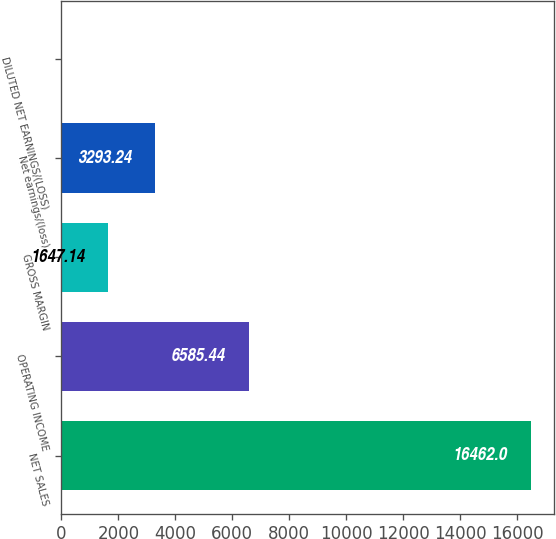<chart> <loc_0><loc_0><loc_500><loc_500><bar_chart><fcel>NET SALES<fcel>OPERATING INCOME<fcel>GROSS MARGIN<fcel>Net earnings/(loss)<fcel>DILUTED NET EARNINGS/(LOSS)<nl><fcel>16462<fcel>6585.44<fcel>1647.14<fcel>3293.24<fcel>1.04<nl></chart> 